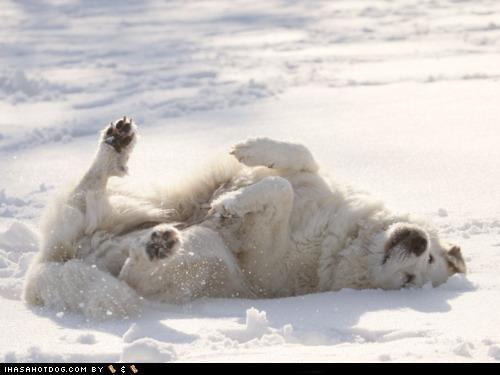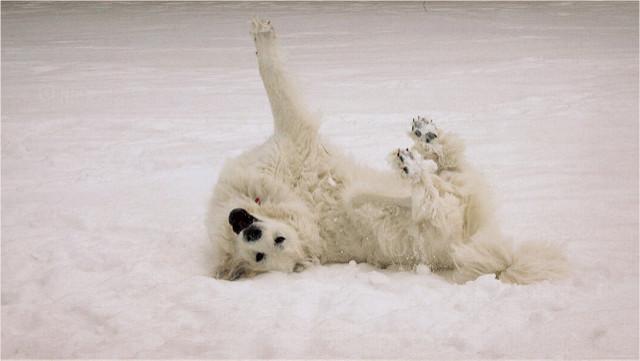The first image is the image on the left, the second image is the image on the right. Assess this claim about the two images: "Each image contains a single white dog, and at least one image shows a dog lying on the snow.". Correct or not? Answer yes or no. Yes. The first image is the image on the left, the second image is the image on the right. Analyze the images presented: Is the assertion "A dogs lies down in the snow in the image on the left." valid? Answer yes or no. Yes. 